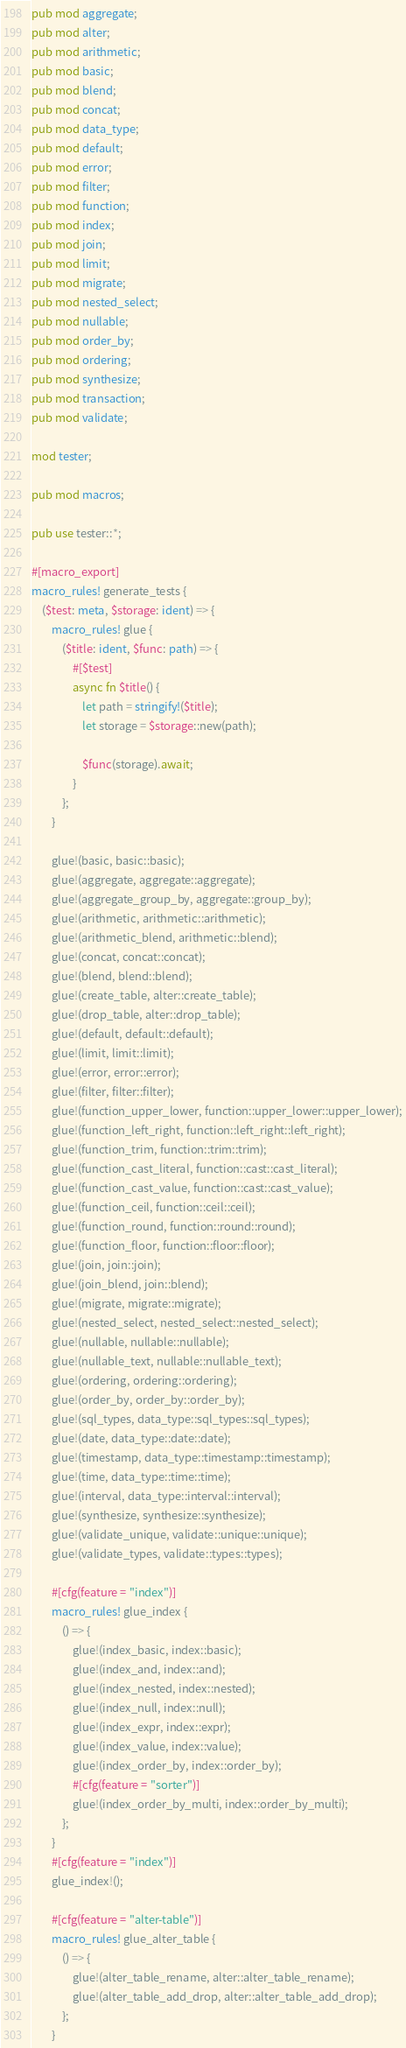<code> <loc_0><loc_0><loc_500><loc_500><_Rust_>pub mod aggregate;
pub mod alter;
pub mod arithmetic;
pub mod basic;
pub mod blend;
pub mod concat;
pub mod data_type;
pub mod default;
pub mod error;
pub mod filter;
pub mod function;
pub mod index;
pub mod join;
pub mod limit;
pub mod migrate;
pub mod nested_select;
pub mod nullable;
pub mod order_by;
pub mod ordering;
pub mod synthesize;
pub mod transaction;
pub mod validate;

mod tester;

pub mod macros;

pub use tester::*;

#[macro_export]
macro_rules! generate_tests {
    ($test: meta, $storage: ident) => {
        macro_rules! glue {
            ($title: ident, $func: path) => {
                #[$test]
                async fn $title() {
                    let path = stringify!($title);
                    let storage = $storage::new(path);

                    $func(storage).await;
                }
            };
        }

        glue!(basic, basic::basic);
        glue!(aggregate, aggregate::aggregate);
        glue!(aggregate_group_by, aggregate::group_by);
        glue!(arithmetic, arithmetic::arithmetic);
        glue!(arithmetic_blend, arithmetic::blend);
        glue!(concat, concat::concat);
        glue!(blend, blend::blend);
        glue!(create_table, alter::create_table);
        glue!(drop_table, alter::drop_table);
        glue!(default, default::default);
        glue!(limit, limit::limit);
        glue!(error, error::error);
        glue!(filter, filter::filter);
        glue!(function_upper_lower, function::upper_lower::upper_lower);
        glue!(function_left_right, function::left_right::left_right);
        glue!(function_trim, function::trim::trim);
        glue!(function_cast_literal, function::cast::cast_literal);
        glue!(function_cast_value, function::cast::cast_value);
        glue!(function_ceil, function::ceil::ceil);
        glue!(function_round, function::round::round);
        glue!(function_floor, function::floor::floor);
        glue!(join, join::join);
        glue!(join_blend, join::blend);
        glue!(migrate, migrate::migrate);
        glue!(nested_select, nested_select::nested_select);
        glue!(nullable, nullable::nullable);
        glue!(nullable_text, nullable::nullable_text);
        glue!(ordering, ordering::ordering);
        glue!(order_by, order_by::order_by);
        glue!(sql_types, data_type::sql_types::sql_types);
        glue!(date, data_type::date::date);
        glue!(timestamp, data_type::timestamp::timestamp);
        glue!(time, data_type::time::time);
        glue!(interval, data_type::interval::interval);
        glue!(synthesize, synthesize::synthesize);
        glue!(validate_unique, validate::unique::unique);
        glue!(validate_types, validate::types::types);

        #[cfg(feature = "index")]
        macro_rules! glue_index {
            () => {
                glue!(index_basic, index::basic);
                glue!(index_and, index::and);
                glue!(index_nested, index::nested);
                glue!(index_null, index::null);
                glue!(index_expr, index::expr);
                glue!(index_value, index::value);
                glue!(index_order_by, index::order_by);
                #[cfg(feature = "sorter")]
                glue!(index_order_by_multi, index::order_by_multi);
            };
        }
        #[cfg(feature = "index")]
        glue_index!();

        #[cfg(feature = "alter-table")]
        macro_rules! glue_alter_table {
            () => {
                glue!(alter_table_rename, alter::alter_table_rename);
                glue!(alter_table_add_drop, alter::alter_table_add_drop);
            };
        }</code> 